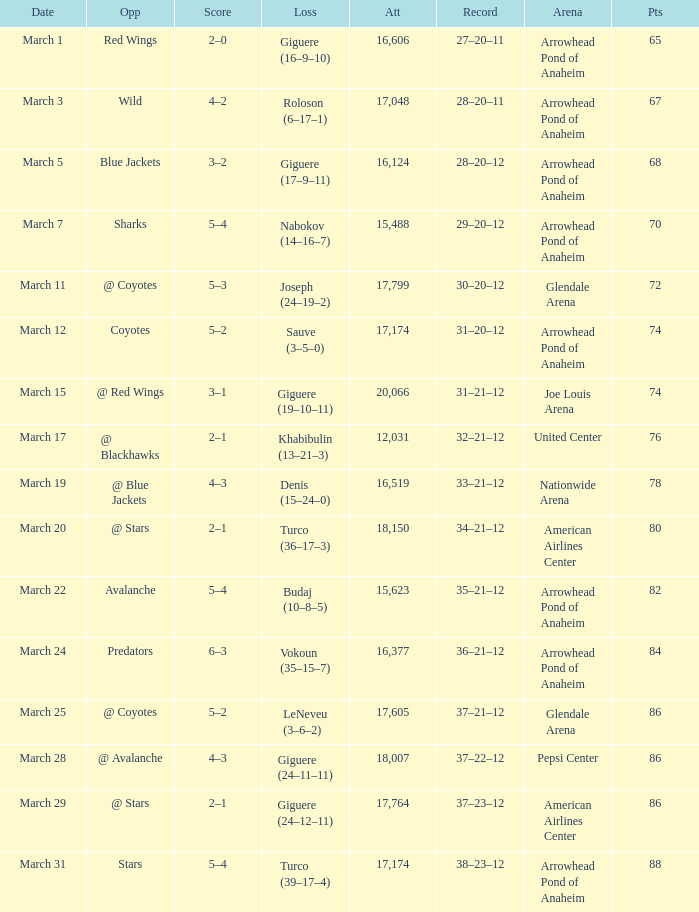What is the Attendance of the game with a Score of 3–2? 1.0. 